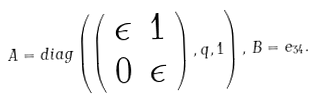<formula> <loc_0><loc_0><loc_500><loc_500>A = d i a g \left ( \left ( \begin{array} { c c } \epsilon & 1 \\ 0 & \epsilon \\ \end{array} \right ) , q , 1 \right ) , \, B = e _ { 3 4 } .</formula> 